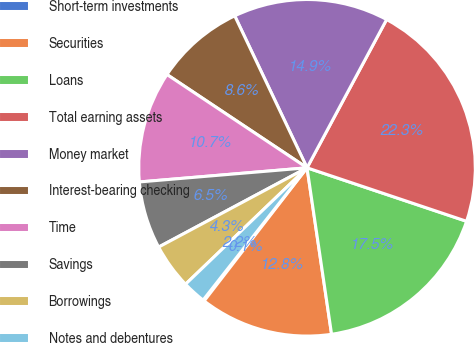<chart> <loc_0><loc_0><loc_500><loc_500><pie_chart><fcel>Short-term investments<fcel>Securities<fcel>Loans<fcel>Total earning assets<fcel>Money market<fcel>Interest-bearing checking<fcel>Time<fcel>Savings<fcel>Borrowings<fcel>Notes and debentures<nl><fcel>0.13%<fcel>12.8%<fcel>17.52%<fcel>22.31%<fcel>14.91%<fcel>8.58%<fcel>10.69%<fcel>6.47%<fcel>4.35%<fcel>2.24%<nl></chart> 